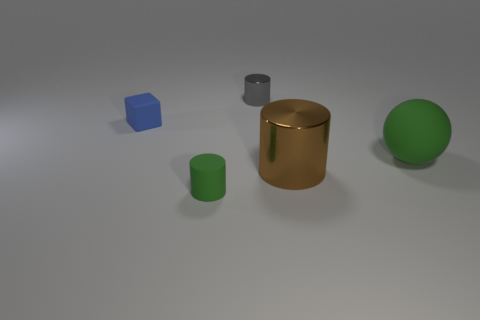Can you describe the placement of all objects in relation to each other? The objects are arranged with ample space between them; a blue cube is positioned on the left, next to it is a small green cylinder, then a large metallic cylinder in the middle, and a green sphere on the far right. 